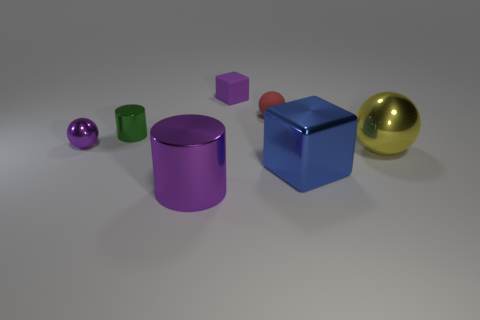Can you tell me about the lighting in the image? Certainly! The image is evenly illuminated by what appears to be diffused lighting, probably from an overhead source. This creates soft shadows directly beneath the objects, offering a sense of depth without harsh contrasts. 